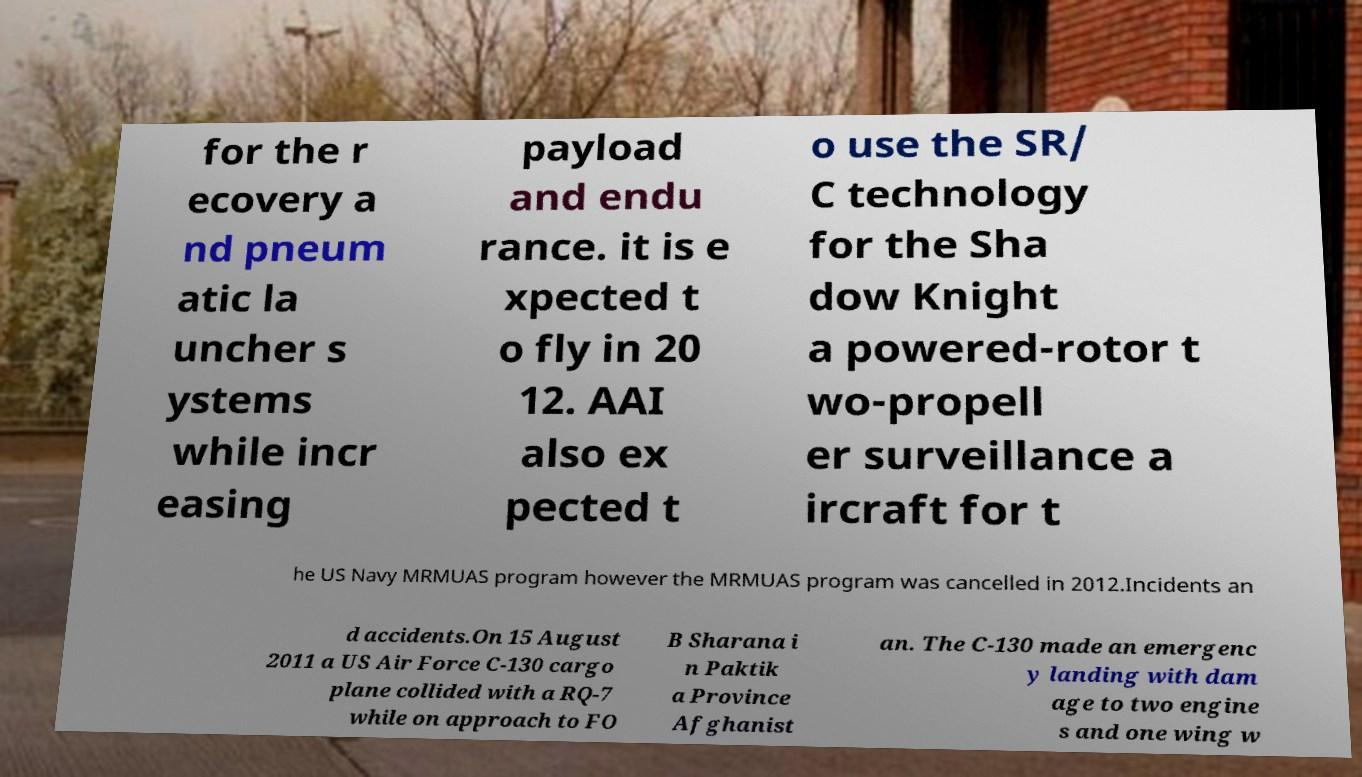There's text embedded in this image that I need extracted. Can you transcribe it verbatim? for the r ecovery a nd pneum atic la uncher s ystems while incr easing payload and endu rance. it is e xpected t o fly in 20 12. AAI also ex pected t o use the SR/ C technology for the Sha dow Knight a powered-rotor t wo-propell er surveillance a ircraft for t he US Navy MRMUAS program however the MRMUAS program was cancelled in 2012.Incidents an d accidents.On 15 August 2011 a US Air Force C-130 cargo plane collided with a RQ-7 while on approach to FO B Sharana i n Paktik a Province Afghanist an. The C-130 made an emergenc y landing with dam age to two engine s and one wing w 